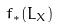Convert formula to latex. <formula><loc_0><loc_0><loc_500><loc_500>f _ { * } ( L _ { X } )</formula> 